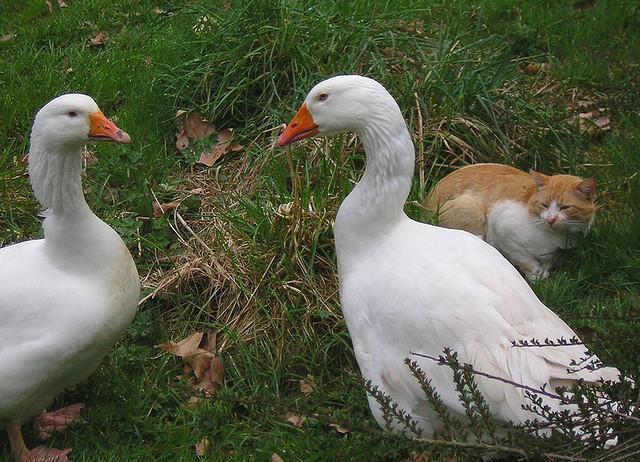How many different kinds of animals are in this picture?
Give a very brief answer. 2. How many birds can you see?
Give a very brief answer. 2. How many bottles on the cutting board are uncorked?
Give a very brief answer. 0. 